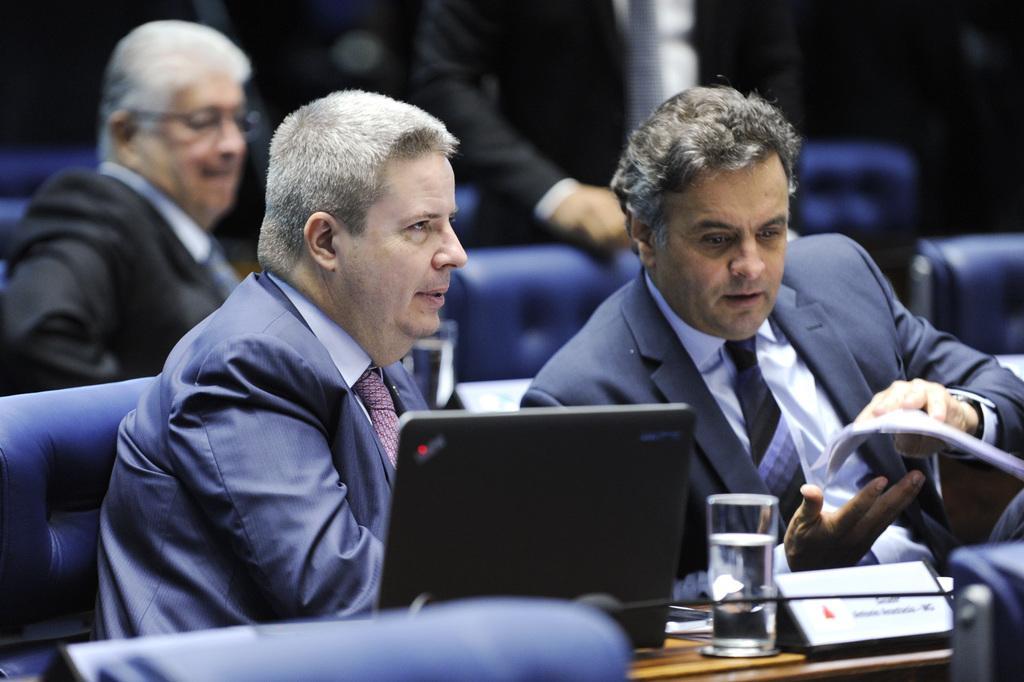How would you summarize this image in a sentence or two? In this image we can see persons sitting on the couches and tables are placed in front of them. On the tables we can see laptop, glass tumblers and name boards. 